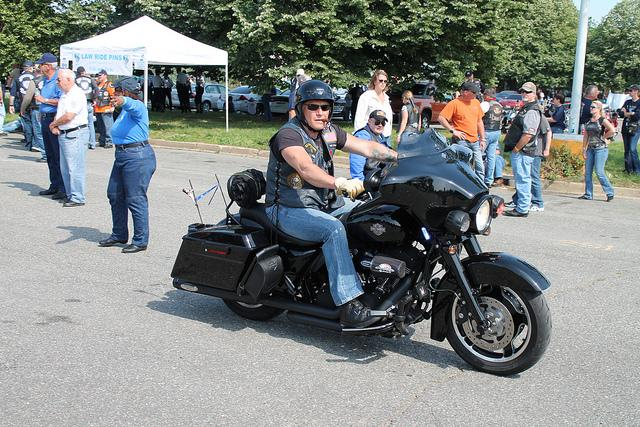What is the man with the helmet on wearing?

Choices:
A) mask
B) bowtie
C) necklace
D) sunglasses sunglasses 